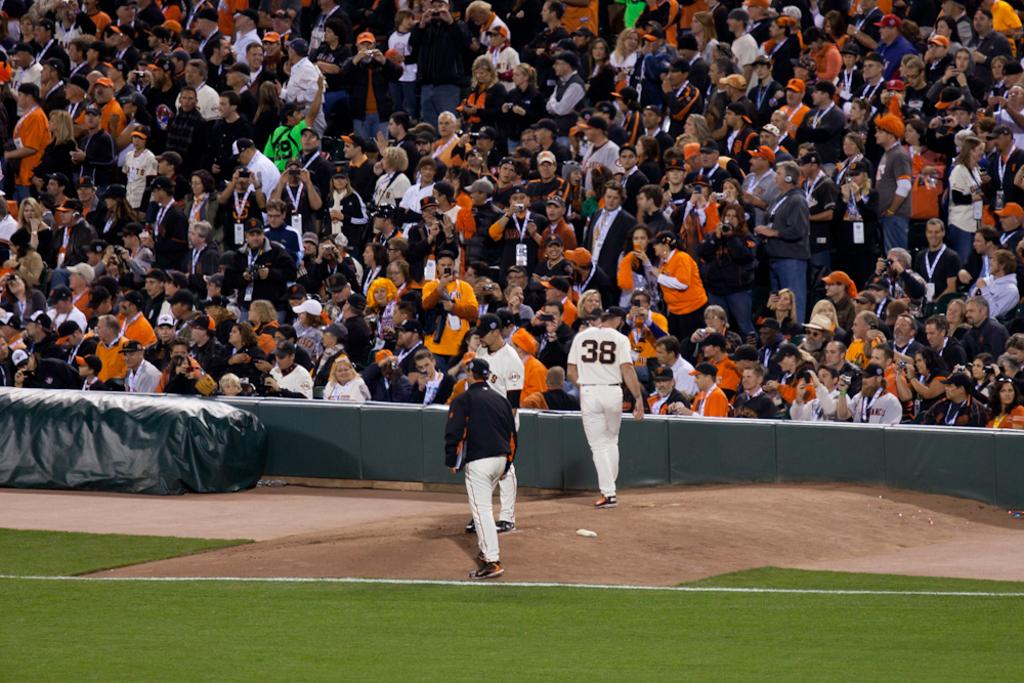<image>
Relay a brief, clear account of the picture shown. Baseball player walking to the stands with a black 38 on his jersey. 